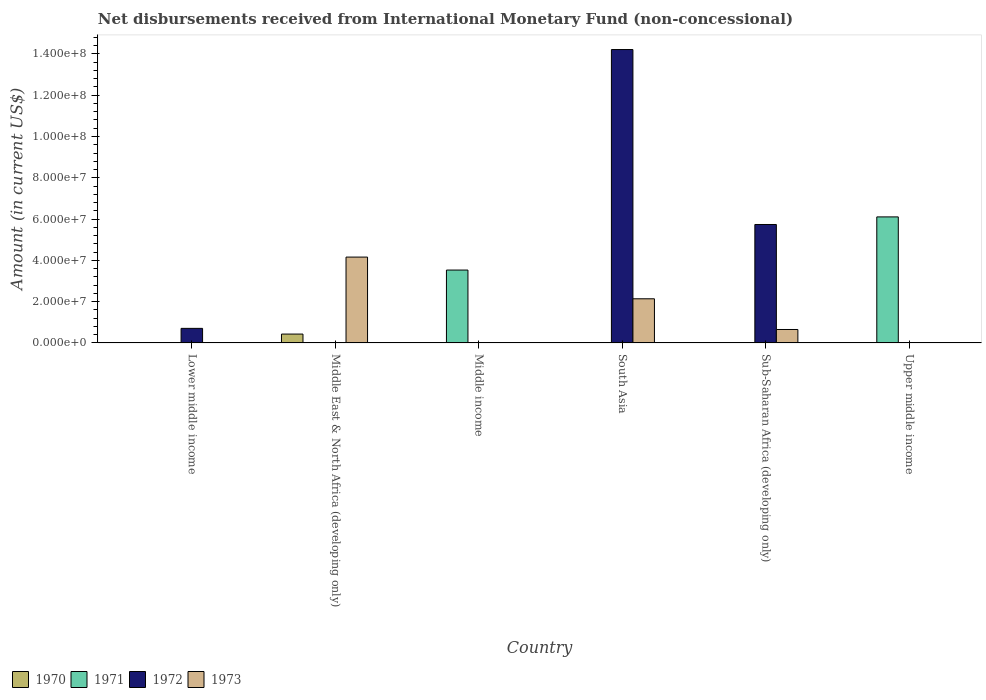How many different coloured bars are there?
Your answer should be compact. 4. Are the number of bars per tick equal to the number of legend labels?
Your answer should be very brief. No. Are the number of bars on each tick of the X-axis equal?
Ensure brevity in your answer.  No. What is the amount of disbursements received from International Monetary Fund in 1973 in Sub-Saharan Africa (developing only)?
Give a very brief answer. 6.51e+06. Across all countries, what is the maximum amount of disbursements received from International Monetary Fund in 1973?
Make the answer very short. 4.16e+07. Across all countries, what is the minimum amount of disbursements received from International Monetary Fund in 1971?
Your answer should be compact. 0. In which country was the amount of disbursements received from International Monetary Fund in 1970 maximum?
Give a very brief answer. Middle East & North Africa (developing only). What is the total amount of disbursements received from International Monetary Fund in 1972 in the graph?
Make the answer very short. 2.07e+08. What is the difference between the amount of disbursements received from International Monetary Fund in 1973 in South Asia and that in Sub-Saharan Africa (developing only)?
Offer a terse response. 1.49e+07. What is the difference between the amount of disbursements received from International Monetary Fund in 1973 in Middle income and the amount of disbursements received from International Monetary Fund in 1972 in Lower middle income?
Your response must be concise. -7.06e+06. What is the average amount of disbursements received from International Monetary Fund in 1973 per country?
Give a very brief answer. 1.16e+07. In how many countries, is the amount of disbursements received from International Monetary Fund in 1973 greater than 112000000 US$?
Offer a terse response. 0. What is the difference between the highest and the second highest amount of disbursements received from International Monetary Fund in 1972?
Offer a very short reply. 8.48e+07. What is the difference between the highest and the lowest amount of disbursements received from International Monetary Fund in 1973?
Provide a short and direct response. 4.16e+07. Is the sum of the amount of disbursements received from International Monetary Fund in 1972 in Lower middle income and Sub-Saharan Africa (developing only) greater than the maximum amount of disbursements received from International Monetary Fund in 1971 across all countries?
Offer a very short reply. Yes. Are all the bars in the graph horizontal?
Provide a succinct answer. No. What is the difference between two consecutive major ticks on the Y-axis?
Ensure brevity in your answer.  2.00e+07. Are the values on the major ticks of Y-axis written in scientific E-notation?
Keep it short and to the point. Yes. Does the graph contain any zero values?
Provide a short and direct response. Yes. Does the graph contain grids?
Offer a very short reply. No. How many legend labels are there?
Ensure brevity in your answer.  4. How are the legend labels stacked?
Ensure brevity in your answer.  Horizontal. What is the title of the graph?
Give a very brief answer. Net disbursements received from International Monetary Fund (non-concessional). What is the label or title of the X-axis?
Your response must be concise. Country. What is the label or title of the Y-axis?
Give a very brief answer. Amount (in current US$). What is the Amount (in current US$) of 1970 in Lower middle income?
Your answer should be compact. 0. What is the Amount (in current US$) in 1971 in Lower middle income?
Make the answer very short. 0. What is the Amount (in current US$) of 1972 in Lower middle income?
Keep it short and to the point. 7.06e+06. What is the Amount (in current US$) of 1973 in Lower middle income?
Offer a very short reply. 0. What is the Amount (in current US$) in 1970 in Middle East & North Africa (developing only)?
Provide a succinct answer. 4.30e+06. What is the Amount (in current US$) in 1972 in Middle East & North Africa (developing only)?
Provide a short and direct response. 0. What is the Amount (in current US$) in 1973 in Middle East & North Africa (developing only)?
Keep it short and to the point. 4.16e+07. What is the Amount (in current US$) in 1970 in Middle income?
Ensure brevity in your answer.  0. What is the Amount (in current US$) of 1971 in Middle income?
Your answer should be very brief. 3.53e+07. What is the Amount (in current US$) of 1973 in Middle income?
Offer a terse response. 0. What is the Amount (in current US$) of 1971 in South Asia?
Offer a very short reply. 0. What is the Amount (in current US$) of 1972 in South Asia?
Offer a very short reply. 1.42e+08. What is the Amount (in current US$) in 1973 in South Asia?
Your response must be concise. 2.14e+07. What is the Amount (in current US$) in 1970 in Sub-Saharan Africa (developing only)?
Offer a very short reply. 0. What is the Amount (in current US$) of 1972 in Sub-Saharan Africa (developing only)?
Provide a short and direct response. 5.74e+07. What is the Amount (in current US$) in 1973 in Sub-Saharan Africa (developing only)?
Your response must be concise. 6.51e+06. What is the Amount (in current US$) of 1970 in Upper middle income?
Ensure brevity in your answer.  0. What is the Amount (in current US$) in 1971 in Upper middle income?
Keep it short and to the point. 6.11e+07. What is the Amount (in current US$) of 1973 in Upper middle income?
Keep it short and to the point. 0. Across all countries, what is the maximum Amount (in current US$) of 1970?
Provide a short and direct response. 4.30e+06. Across all countries, what is the maximum Amount (in current US$) in 1971?
Keep it short and to the point. 6.11e+07. Across all countries, what is the maximum Amount (in current US$) of 1972?
Your answer should be very brief. 1.42e+08. Across all countries, what is the maximum Amount (in current US$) in 1973?
Keep it short and to the point. 4.16e+07. Across all countries, what is the minimum Amount (in current US$) of 1970?
Give a very brief answer. 0. Across all countries, what is the minimum Amount (in current US$) of 1972?
Offer a terse response. 0. What is the total Amount (in current US$) in 1970 in the graph?
Offer a terse response. 4.30e+06. What is the total Amount (in current US$) of 1971 in the graph?
Your response must be concise. 9.64e+07. What is the total Amount (in current US$) of 1972 in the graph?
Ensure brevity in your answer.  2.07e+08. What is the total Amount (in current US$) in 1973 in the graph?
Your answer should be compact. 6.95e+07. What is the difference between the Amount (in current US$) of 1972 in Lower middle income and that in South Asia?
Offer a terse response. -1.35e+08. What is the difference between the Amount (in current US$) in 1972 in Lower middle income and that in Sub-Saharan Africa (developing only)?
Keep it short and to the point. -5.03e+07. What is the difference between the Amount (in current US$) in 1973 in Middle East & North Africa (developing only) and that in South Asia?
Offer a very short reply. 2.02e+07. What is the difference between the Amount (in current US$) of 1973 in Middle East & North Africa (developing only) and that in Sub-Saharan Africa (developing only)?
Your answer should be very brief. 3.51e+07. What is the difference between the Amount (in current US$) in 1971 in Middle income and that in Upper middle income?
Your answer should be compact. -2.57e+07. What is the difference between the Amount (in current US$) in 1972 in South Asia and that in Sub-Saharan Africa (developing only)?
Provide a succinct answer. 8.48e+07. What is the difference between the Amount (in current US$) in 1973 in South Asia and that in Sub-Saharan Africa (developing only)?
Offer a very short reply. 1.49e+07. What is the difference between the Amount (in current US$) in 1972 in Lower middle income and the Amount (in current US$) in 1973 in Middle East & North Africa (developing only)?
Your response must be concise. -3.45e+07. What is the difference between the Amount (in current US$) in 1972 in Lower middle income and the Amount (in current US$) in 1973 in South Asia?
Make the answer very short. -1.43e+07. What is the difference between the Amount (in current US$) in 1972 in Lower middle income and the Amount (in current US$) in 1973 in Sub-Saharan Africa (developing only)?
Provide a succinct answer. 5.46e+05. What is the difference between the Amount (in current US$) of 1970 in Middle East & North Africa (developing only) and the Amount (in current US$) of 1971 in Middle income?
Ensure brevity in your answer.  -3.10e+07. What is the difference between the Amount (in current US$) in 1970 in Middle East & North Africa (developing only) and the Amount (in current US$) in 1972 in South Asia?
Your answer should be compact. -1.38e+08. What is the difference between the Amount (in current US$) of 1970 in Middle East & North Africa (developing only) and the Amount (in current US$) of 1973 in South Asia?
Your response must be concise. -1.71e+07. What is the difference between the Amount (in current US$) in 1970 in Middle East & North Africa (developing only) and the Amount (in current US$) in 1972 in Sub-Saharan Africa (developing only)?
Your answer should be very brief. -5.31e+07. What is the difference between the Amount (in current US$) of 1970 in Middle East & North Africa (developing only) and the Amount (in current US$) of 1973 in Sub-Saharan Africa (developing only)?
Make the answer very short. -2.21e+06. What is the difference between the Amount (in current US$) in 1970 in Middle East & North Africa (developing only) and the Amount (in current US$) in 1971 in Upper middle income?
Provide a short and direct response. -5.68e+07. What is the difference between the Amount (in current US$) in 1971 in Middle income and the Amount (in current US$) in 1972 in South Asia?
Offer a terse response. -1.07e+08. What is the difference between the Amount (in current US$) in 1971 in Middle income and the Amount (in current US$) in 1973 in South Asia?
Your answer should be compact. 1.39e+07. What is the difference between the Amount (in current US$) of 1971 in Middle income and the Amount (in current US$) of 1972 in Sub-Saharan Africa (developing only)?
Give a very brief answer. -2.21e+07. What is the difference between the Amount (in current US$) in 1971 in Middle income and the Amount (in current US$) in 1973 in Sub-Saharan Africa (developing only)?
Give a very brief answer. 2.88e+07. What is the difference between the Amount (in current US$) in 1972 in South Asia and the Amount (in current US$) in 1973 in Sub-Saharan Africa (developing only)?
Give a very brief answer. 1.36e+08. What is the average Amount (in current US$) of 1970 per country?
Ensure brevity in your answer.  7.17e+05. What is the average Amount (in current US$) in 1971 per country?
Give a very brief answer. 1.61e+07. What is the average Amount (in current US$) of 1972 per country?
Your answer should be very brief. 3.44e+07. What is the average Amount (in current US$) in 1973 per country?
Offer a very short reply. 1.16e+07. What is the difference between the Amount (in current US$) in 1970 and Amount (in current US$) in 1973 in Middle East & North Africa (developing only)?
Ensure brevity in your answer.  -3.73e+07. What is the difference between the Amount (in current US$) of 1972 and Amount (in current US$) of 1973 in South Asia?
Your response must be concise. 1.21e+08. What is the difference between the Amount (in current US$) of 1972 and Amount (in current US$) of 1973 in Sub-Saharan Africa (developing only)?
Your answer should be compact. 5.09e+07. What is the ratio of the Amount (in current US$) of 1972 in Lower middle income to that in South Asia?
Your answer should be compact. 0.05. What is the ratio of the Amount (in current US$) in 1972 in Lower middle income to that in Sub-Saharan Africa (developing only)?
Keep it short and to the point. 0.12. What is the ratio of the Amount (in current US$) in 1973 in Middle East & North Africa (developing only) to that in South Asia?
Give a very brief answer. 1.94. What is the ratio of the Amount (in current US$) of 1973 in Middle East & North Africa (developing only) to that in Sub-Saharan Africa (developing only)?
Provide a succinct answer. 6.39. What is the ratio of the Amount (in current US$) of 1971 in Middle income to that in Upper middle income?
Give a very brief answer. 0.58. What is the ratio of the Amount (in current US$) of 1972 in South Asia to that in Sub-Saharan Africa (developing only)?
Your response must be concise. 2.48. What is the ratio of the Amount (in current US$) in 1973 in South Asia to that in Sub-Saharan Africa (developing only)?
Keep it short and to the point. 3.29. What is the difference between the highest and the second highest Amount (in current US$) of 1972?
Make the answer very short. 8.48e+07. What is the difference between the highest and the second highest Amount (in current US$) in 1973?
Your response must be concise. 2.02e+07. What is the difference between the highest and the lowest Amount (in current US$) in 1970?
Your response must be concise. 4.30e+06. What is the difference between the highest and the lowest Amount (in current US$) of 1971?
Your answer should be compact. 6.11e+07. What is the difference between the highest and the lowest Amount (in current US$) of 1972?
Give a very brief answer. 1.42e+08. What is the difference between the highest and the lowest Amount (in current US$) of 1973?
Give a very brief answer. 4.16e+07. 